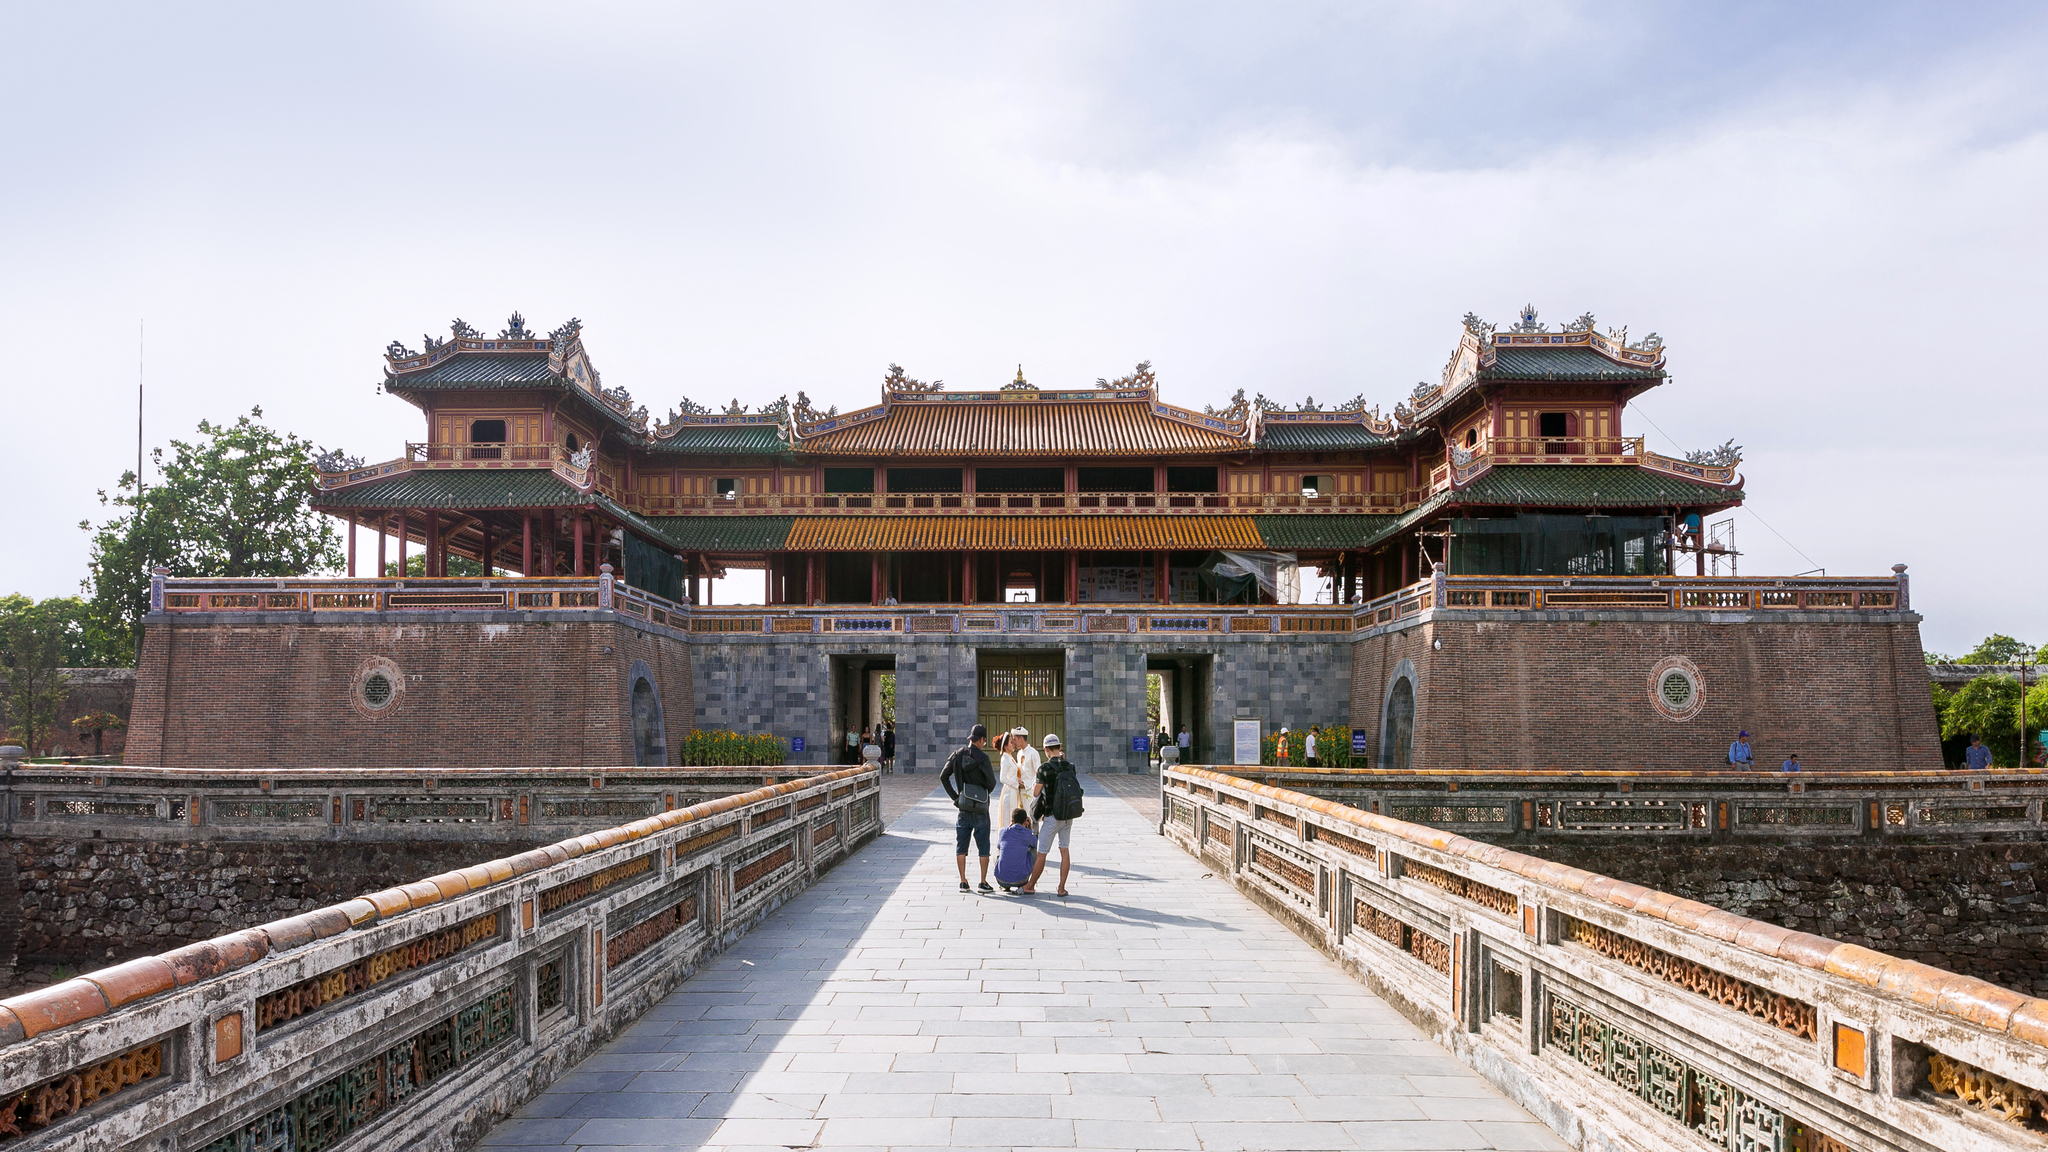What could be the thoughts of the people standing at the entrance? The people standing at the entrance of the Imperial Citadel likely feel a mix of awe and curiosity. They might be contemplating the sheer historical significance of the structure before them, imagining the countless historical figures and events that have taken place within its walls. There might be a sense of reverence for the architectural beauty and the grandeur of the citadel. As they stand in front of this monumental gate, they could be eagerly anticipating the journey through time they are about to embark on as they explore the citadel’s many wonders. 